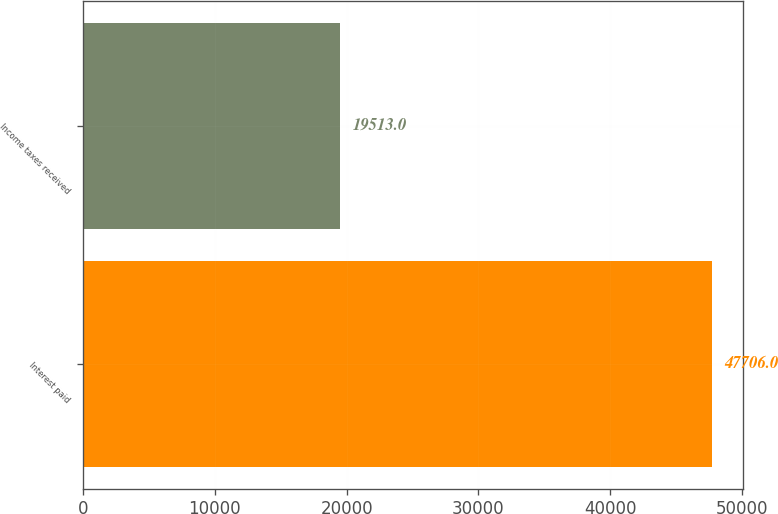Convert chart. <chart><loc_0><loc_0><loc_500><loc_500><bar_chart><fcel>Interest paid<fcel>Income taxes received<nl><fcel>47706<fcel>19513<nl></chart> 